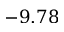<formula> <loc_0><loc_0><loc_500><loc_500>- 9 . 7 8</formula> 